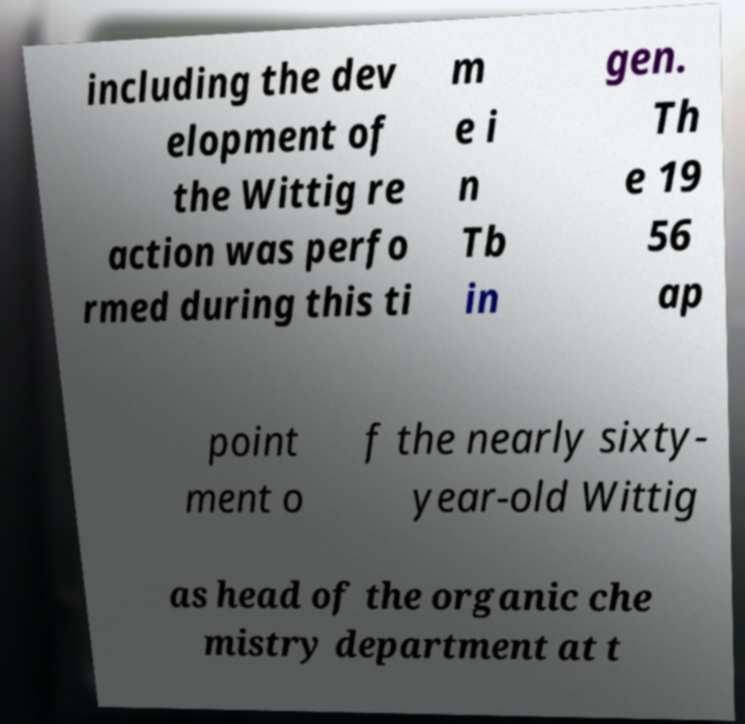Can you read and provide the text displayed in the image?This photo seems to have some interesting text. Can you extract and type it out for me? including the dev elopment of the Wittig re action was perfo rmed during this ti m e i n Tb in gen. Th e 19 56 ap point ment o f the nearly sixty- year-old Wittig as head of the organic che mistry department at t 